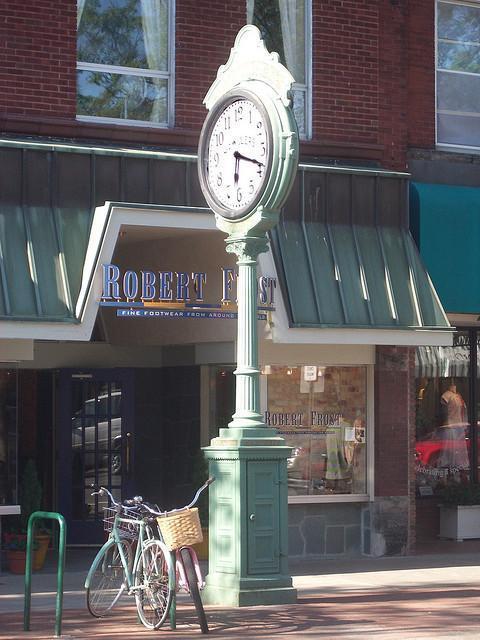How many bicycles are visible?
Give a very brief answer. 2. 